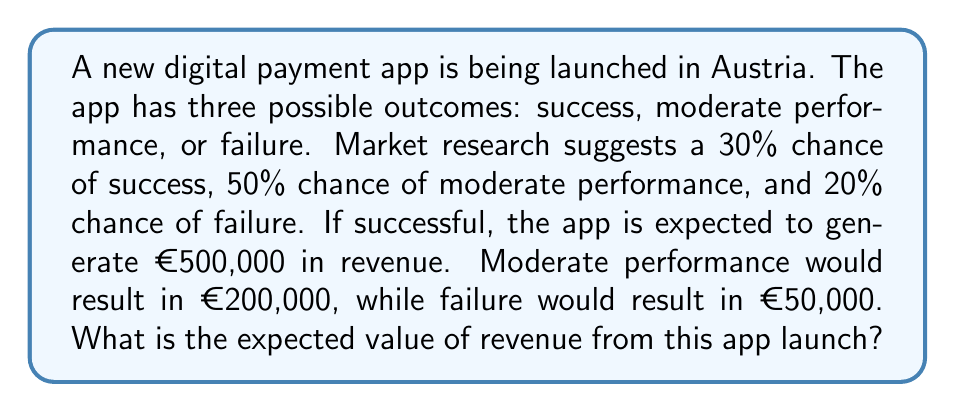Can you answer this question? To calculate the expected value, we need to multiply each possible outcome by its probability and then sum these products. Let's break it down step-by-step:

1. Define the probabilities and revenues:
   - Success: $P(S) = 0.30$, Revenue = €500,000
   - Moderate: $P(M) = 0.50$, Revenue = €200,000
   - Failure: $P(F) = 0.20$, Revenue = €50,000

2. Calculate the expected value for each outcome:
   - Success: $E(S) = 0.30 \times €500,000 = €150,000$
   - Moderate: $E(M) = 0.50 \times €200,000 = €100,000$
   - Failure: $E(F) = 0.20 \times €50,000 = €10,000$

3. Sum the expected values to get the total expected value:

   $$E(\text{Revenue}) = E(S) + E(M) + E(F)$$
   $$E(\text{Revenue}) = €150,000 + €100,000 + €10,000 = €260,000$$

Therefore, the expected value of revenue from the new payment app launch is €260,000.
Answer: €260,000 